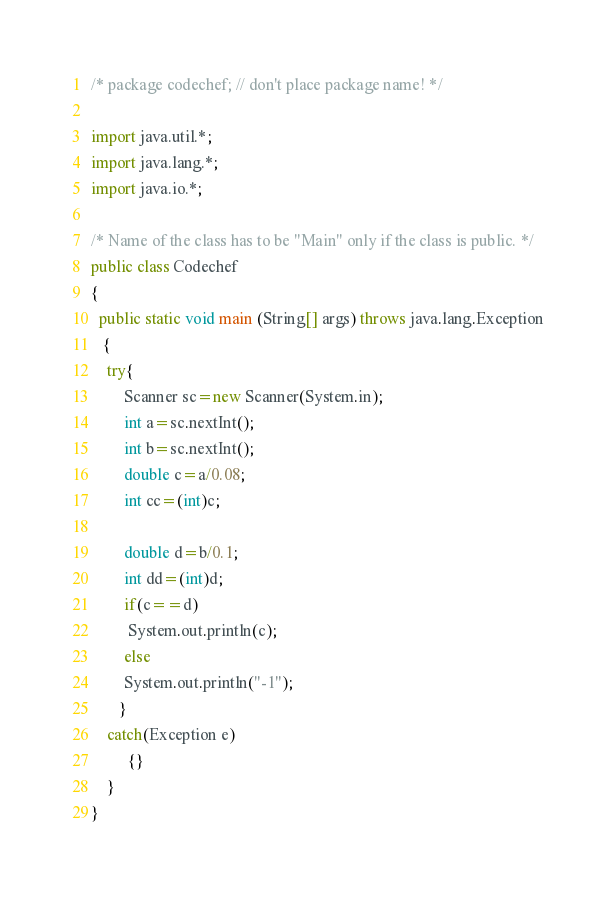Convert code to text. <code><loc_0><loc_0><loc_500><loc_500><_Java_>/* package codechef; // don't place package name! */

import java.util.*;
import java.lang.*;
import java.io.*;

/* Name of the class has to be "Main" only if the class is public. */
public class Codechef
{
  public static void main (String[] args) throws java.lang.Exception
   {
	try{
	    Scanner sc=new Scanner(System.in);
	    int a=sc.nextInt();
	    int b=sc.nextInt();
	    double c=a/0.08;
	    int cc=(int)c;
	    
	    double d=b/0.1;
	    int dd=(int)d;
	    if(c==d)
	     System.out.println(c);
	    else
	    System.out.println("-1");
       }     
	catch(Exception e)
		 {}
	}
}
</code> 